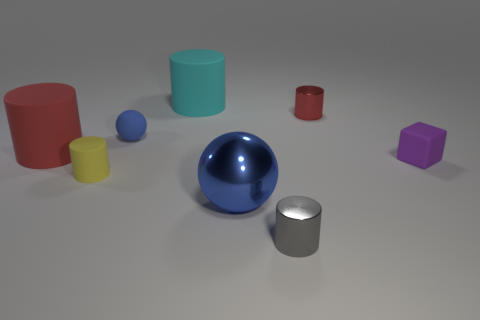The gray shiny cylinder has what size?
Your response must be concise. Small. There is a tiny rubber thing that is both on the left side of the tiny gray cylinder and behind the tiny yellow cylinder; what shape is it?
Make the answer very short. Sphere. There is another large matte object that is the same shape as the big red object; what is its color?
Your response must be concise. Cyan. How many things are either tiny objects left of the tiny gray metallic cylinder or objects that are behind the tiny gray cylinder?
Keep it short and to the point. 7. The big red thing is what shape?
Your answer should be compact. Cylinder. How many tiny yellow things are the same material as the cube?
Keep it short and to the point. 1. The big metallic object has what color?
Give a very brief answer. Blue. What is the color of the rubber cylinder that is the same size as the purple object?
Your answer should be compact. Yellow. Are there any small matte balls of the same color as the metallic ball?
Ensure brevity in your answer.  Yes. Do the red thing behind the blue rubber object and the small rubber thing in front of the tiny purple rubber thing have the same shape?
Ensure brevity in your answer.  Yes. 